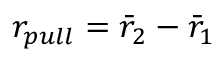Convert formula to latex. <formula><loc_0><loc_0><loc_500><loc_500>r _ { p u l l } = \bar { r } _ { 2 } - \bar { r } _ { 1 }</formula> 